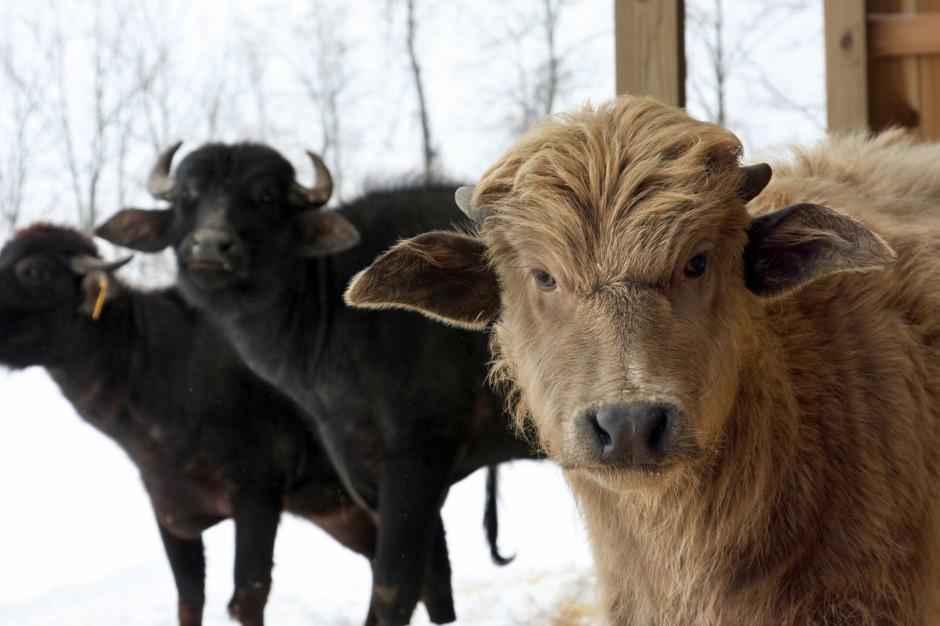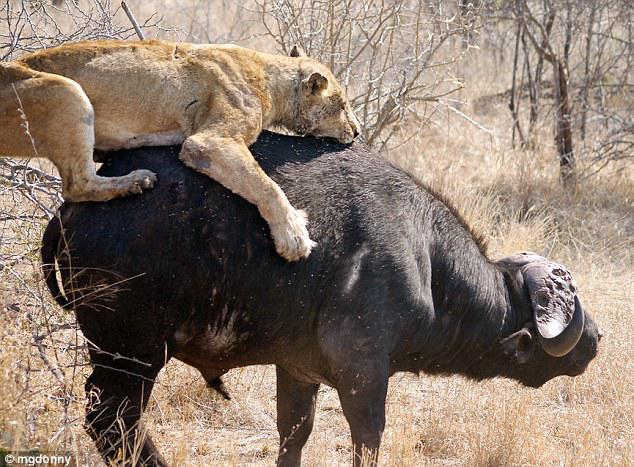The first image is the image on the left, the second image is the image on the right. Given the left and right images, does the statement "The left image includes a forward-facing buffalo with other buffalo in the background at the left, and the right image shows a buffalo with a different type of animal on its back." hold true? Answer yes or no. Yes. The first image is the image on the left, the second image is the image on the right. Assess this claim about the two images: "In at least one image there is a single round horned ox standing next to it brown cafe". Correct or not? Answer yes or no. No. 